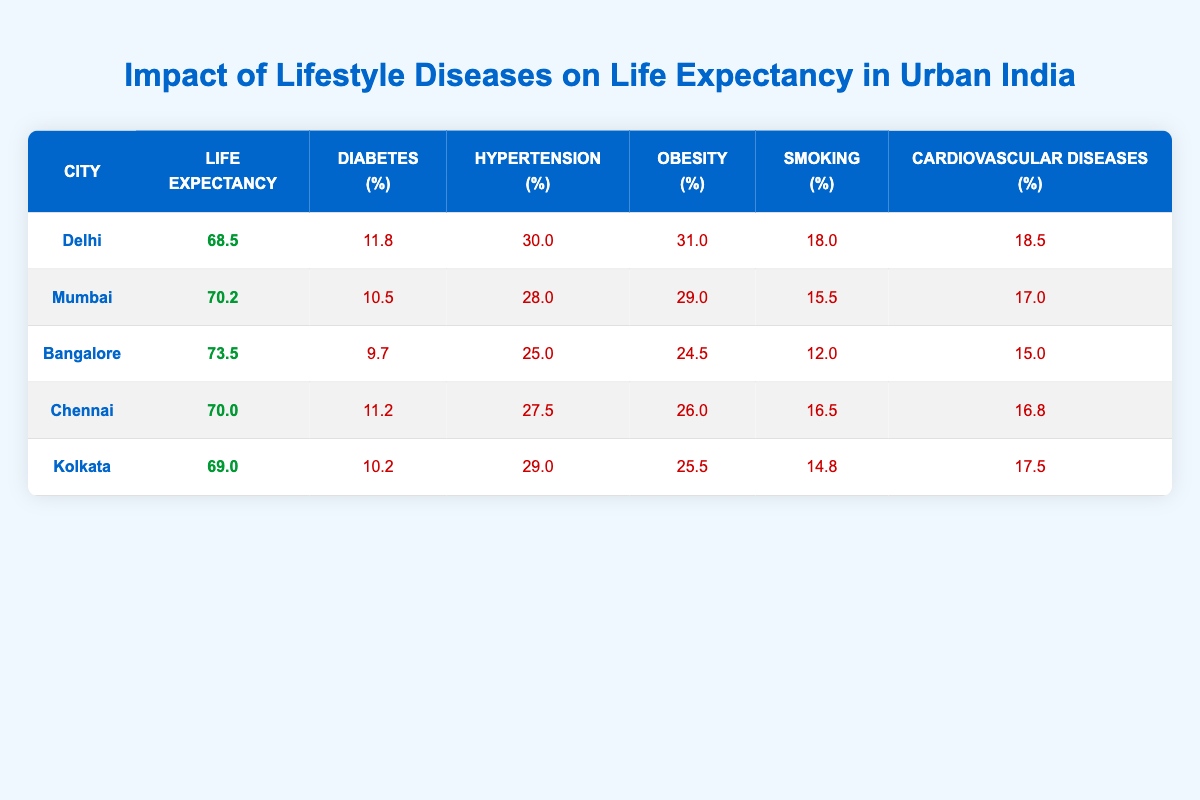What is the life expectancy in Delhi? From the table, the life expectancy for Delhi is stated clearly in the corresponding row.
Answer: 68.5 Which city has the highest prevalence of obesity? By examining the obesity percentage in each city's row, we find that Delhi has the highest prevalence at 31.0%.
Answer: Delhi Is the prevalence of diabetes higher in Chennai than in Kolkata? The table shows diabetes prevalence in Chennai as 11.2% and in Kolkata as 10.2%. Since 11.2% is greater than 10.2%, the prevalence of diabetes is indeed higher in Chennai.
Answer: Yes What is the average life expectancy of the cities listed? To calculate the average, sum the life expectancies (68.5 + 70.2 + 73.5 + 70.0 + 69.0 = 351.2) and divide by the number of cities (5), which results in 351.2 / 5 = 70.24.
Answer: 70.24 Which city has the lowest percentage of smoking prevalence? By comparing the smoking percentages in the table, we see Bangalore has the lowest at 12.0%.
Answer: Bangalore Is the sum of diabetes and cardiovascular diseases prevalence higher in Mumbai than in Chennai? For Mumbai, the sum is 10.5% (diabetes) + 17.0% (cardiovascular diseases) = 27.5%. For Chennai, the sum is 11.2% + 16.8% = 28.0%. Since 27.5% is less than 28.0%, it is not higher in Mumbai.
Answer: No Which city has the highest life expectancy, and what is its value? By reviewing the life expectancy values across the table, Bangalore has the highest at 73.5 years.
Answer: Bangalore, 73.5 If we consider only the cities with life expectancy below 70, what is the average prevalence of smoking in those cities? The cities with life expectancy below 70 are Delhi (18.0%) and Kolkata (14.8%). Their average smoking prevalence is (18.0% + 14.8%) / 2 = 16.4%.
Answer: 16.4 Is it possible to say that cities with higher obesity rates have lower life expectancy? By comparing the data, we can see that Delhi, with the highest obesity rate of 31.0%, has the lowest life expectancy at 68.5. However, this trend is not consistent among all cities, as Chennai has a lower obesity rate but a life expectancy of 70.0. A detailed analysis is needed to confirm.
Answer: No, not consistently 